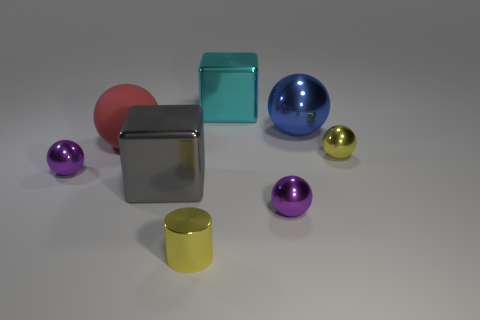What number of matte objects are large gray things or cylinders?
Offer a terse response. 0. There is a big cube that is behind the small purple object that is behind the gray block; what color is it?
Your response must be concise. Cyan. Is the material of the gray block the same as the big ball right of the small shiny cylinder?
Ensure brevity in your answer.  Yes. There is a large matte thing in front of the block that is on the right side of the cube in front of the blue thing; what is its color?
Provide a succinct answer. Red. Are there more small objects than objects?
Your response must be concise. No. What number of purple shiny objects are both to the right of the rubber thing and left of the red rubber thing?
Provide a succinct answer. 0. How many big gray metal things are on the right side of the big block in front of the blue object?
Keep it short and to the point. 0. Do the purple metallic sphere that is left of the big rubber thing and the cube that is behind the large red thing have the same size?
Provide a succinct answer. No. How many cyan blocks are there?
Make the answer very short. 1. What number of small yellow things have the same material as the cyan object?
Keep it short and to the point. 2. 